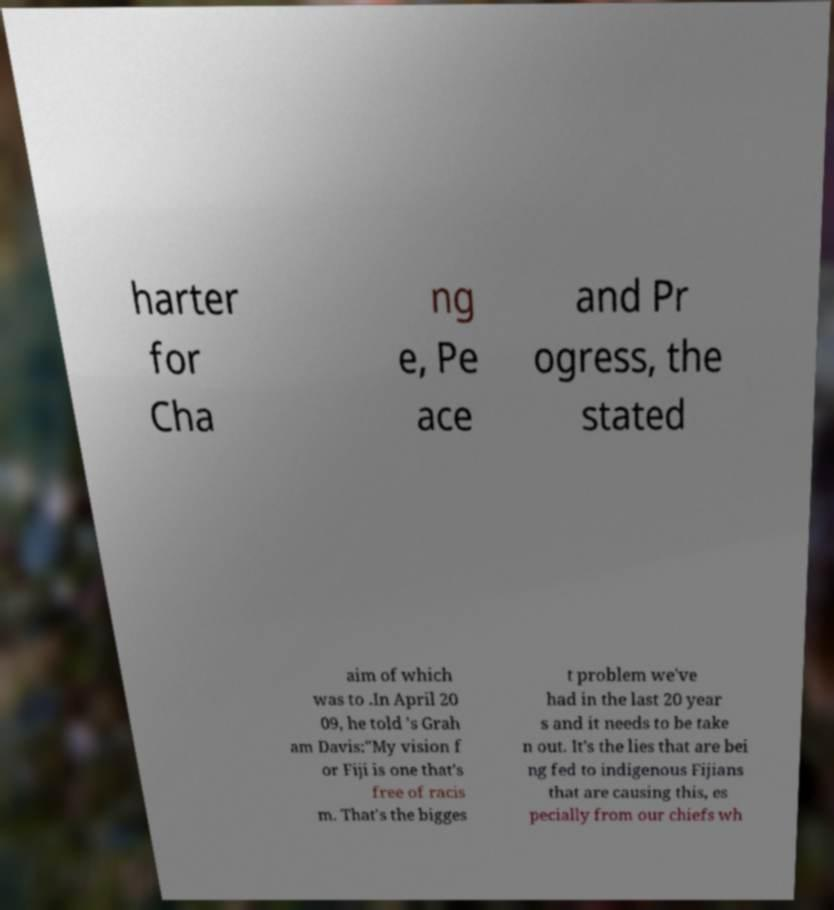Please read and relay the text visible in this image. What does it say? harter for Cha ng e, Pe ace and Pr ogress, the stated aim of which was to .In April 20 09, he told 's Grah am Davis:"My vision f or Fiji is one that's free of racis m. That's the bigges t problem we've had in the last 20 year s and it needs to be take n out. It's the lies that are bei ng fed to indigenous Fijians that are causing this, es pecially from our chiefs wh 